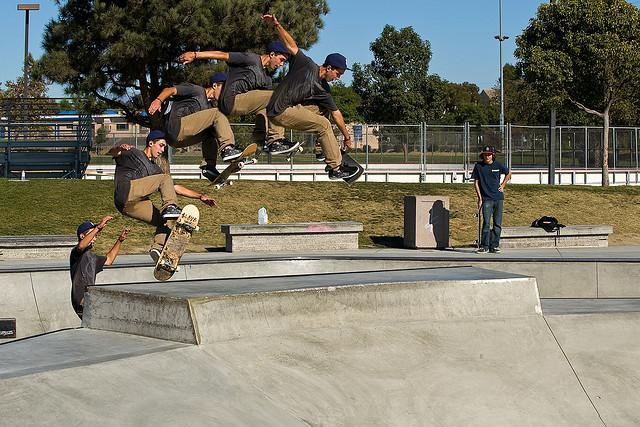How many people wearing tan pants and black shirts are seen here? one 